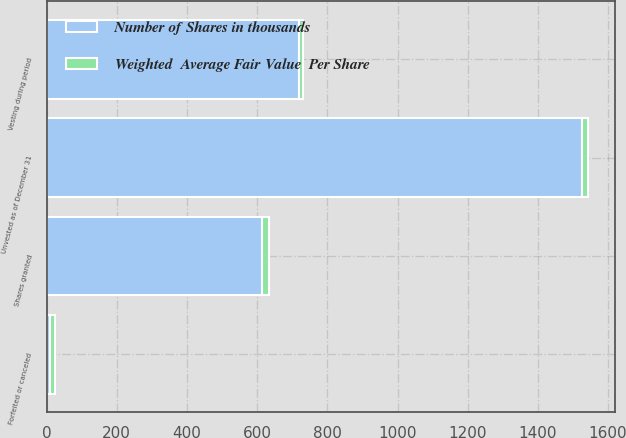<chart> <loc_0><loc_0><loc_500><loc_500><stacked_bar_chart><ecel><fcel>Unvested as of December 31<fcel>Shares granted<fcel>Vesting during period<fcel>Forfeited or canceled<nl><fcel>Number of Shares in thousands<fcel>1526<fcel>613<fcel>718<fcel>9<nl><fcel>Weighted  Average Fair Value  Per Share<fcel>17.2<fcel>20.31<fcel>12.58<fcel>15.2<nl></chart> 